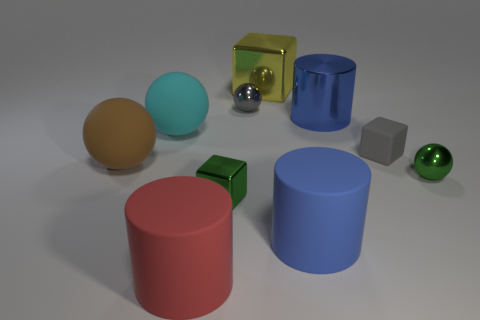Subtract all red blocks. How many blue cylinders are left? 2 Subtract all small green metallic balls. How many balls are left? 3 Subtract all cyan balls. How many balls are left? 3 Subtract 2 spheres. How many spheres are left? 2 Subtract all blue balls. Subtract all gray cubes. How many balls are left? 4 Subtract 0 red balls. How many objects are left? 10 Subtract all spheres. How many objects are left? 6 Subtract all tiny gray blocks. Subtract all small purple shiny things. How many objects are left? 9 Add 9 tiny gray matte blocks. How many tiny gray matte blocks are left? 10 Add 5 big metallic cylinders. How many big metallic cylinders exist? 6 